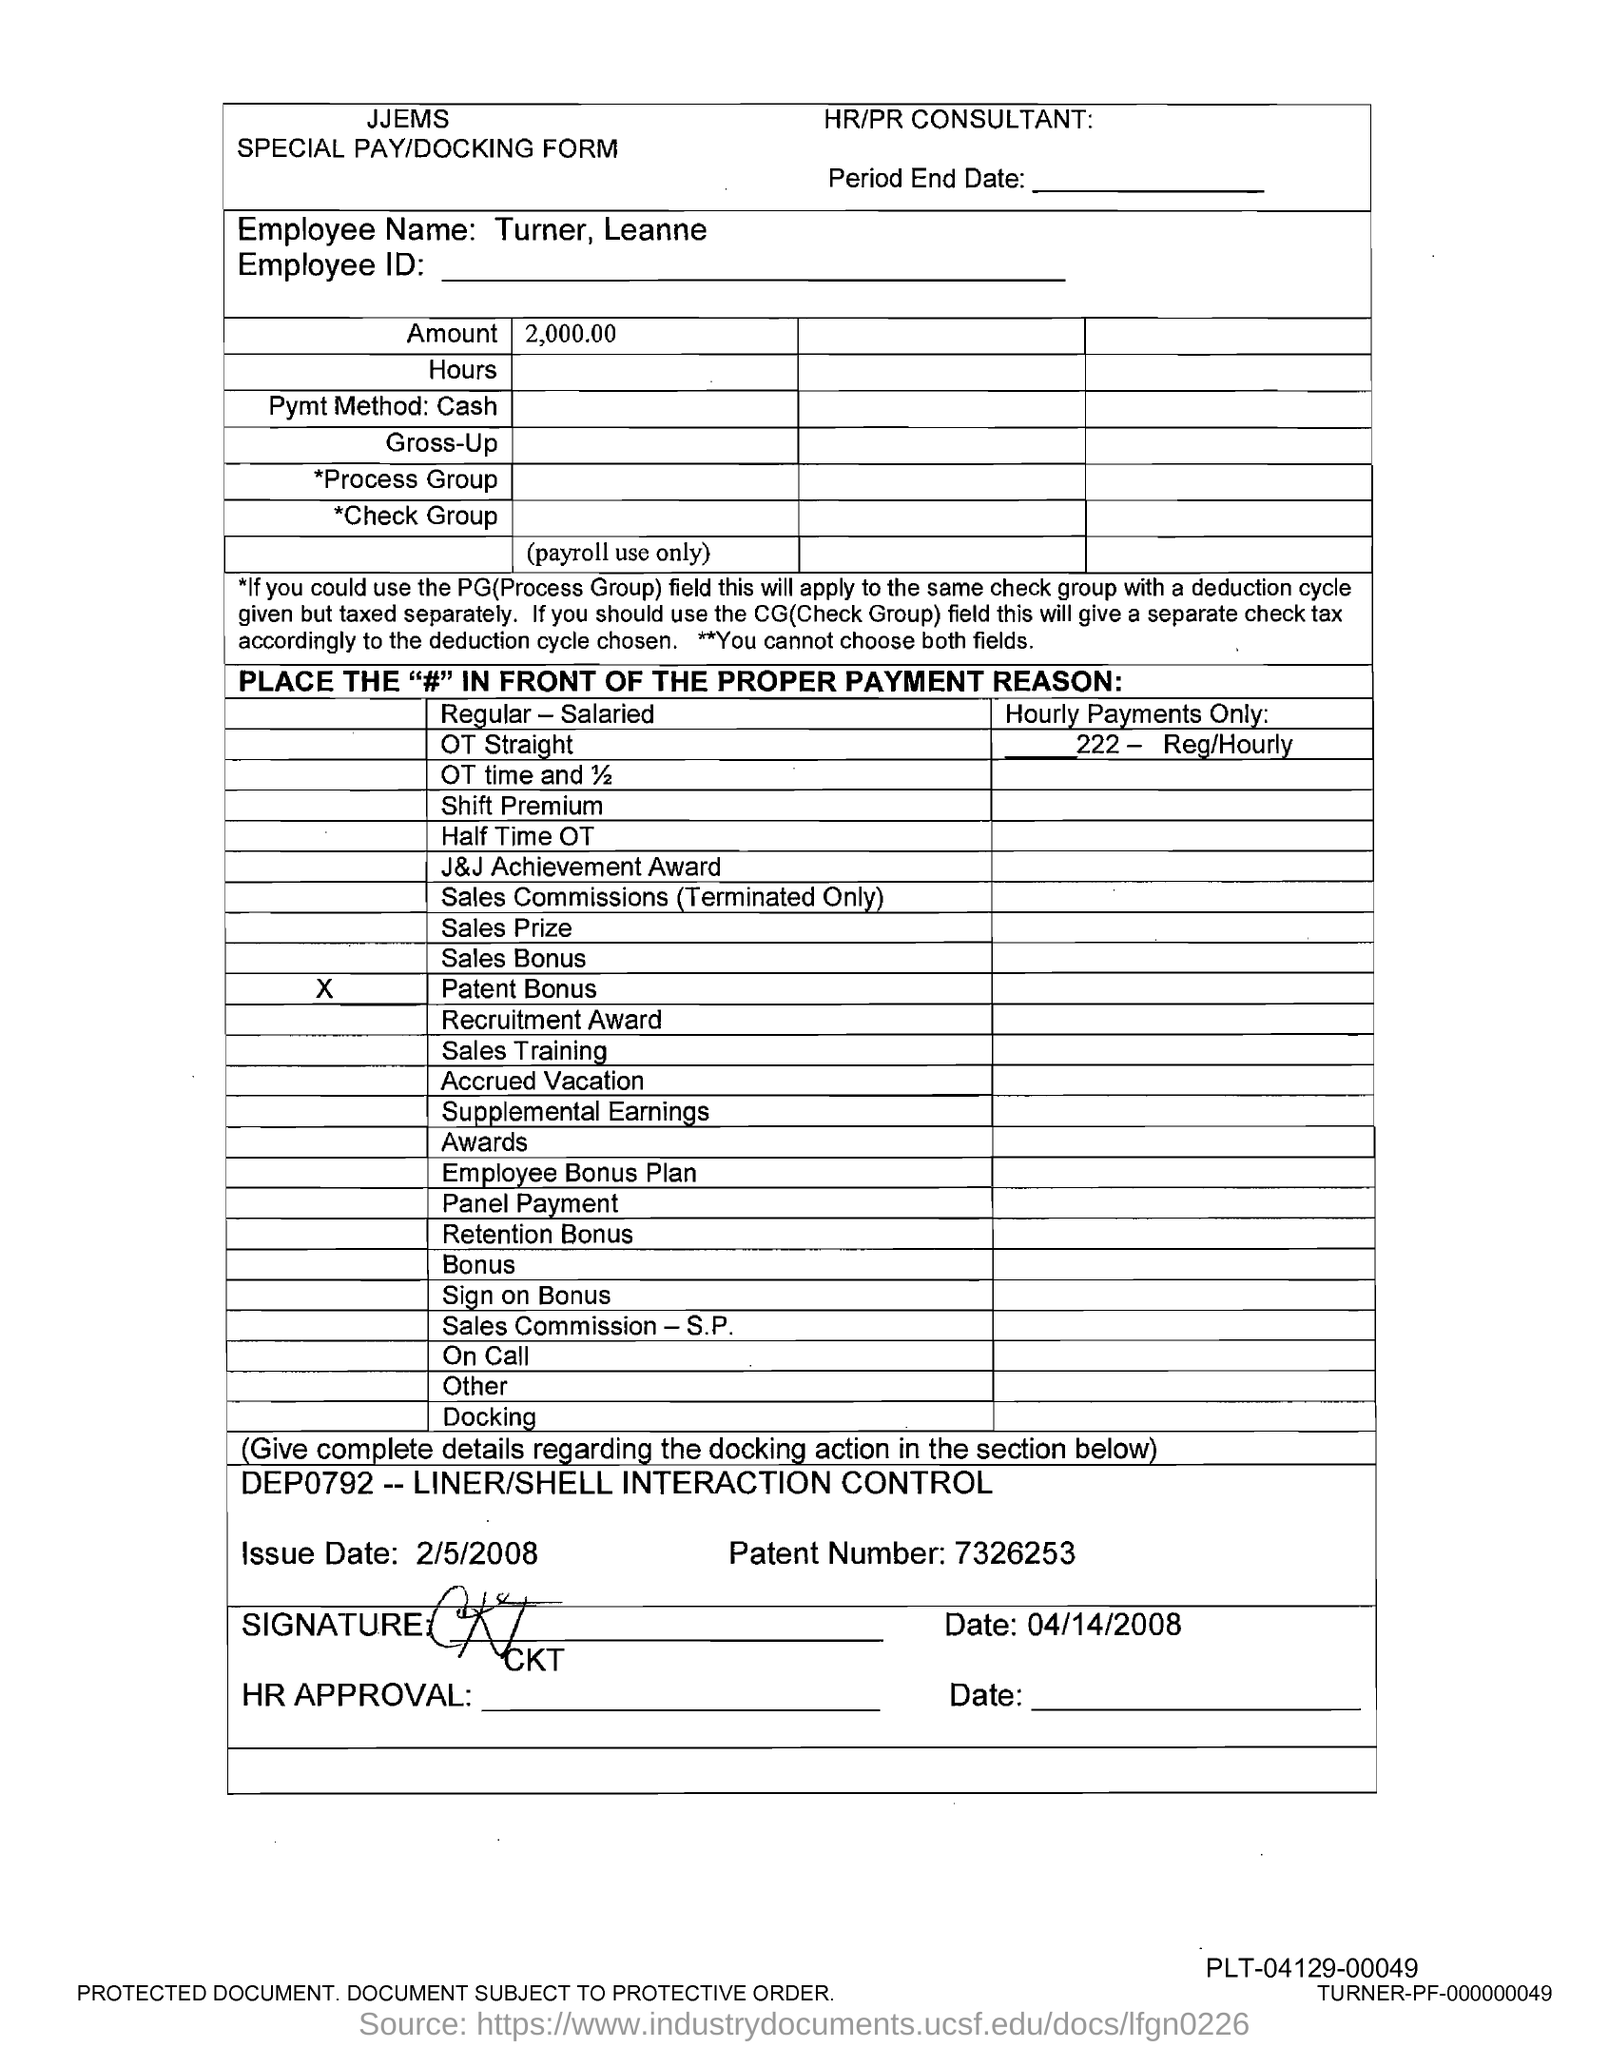Highlight a few significant elements in this photo. The patent number is 7326253. The amount is 2,000.00. 